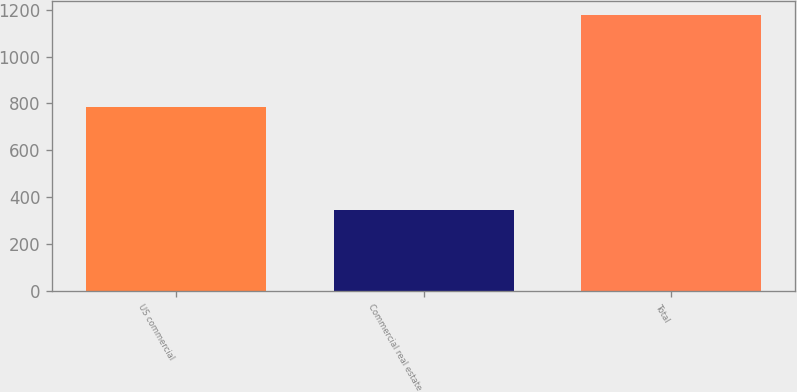Convert chart to OTSL. <chart><loc_0><loc_0><loc_500><loc_500><bar_chart><fcel>US commercial<fcel>Commercial real estate<fcel>Total<nl><fcel>785<fcel>346<fcel>1177<nl></chart> 